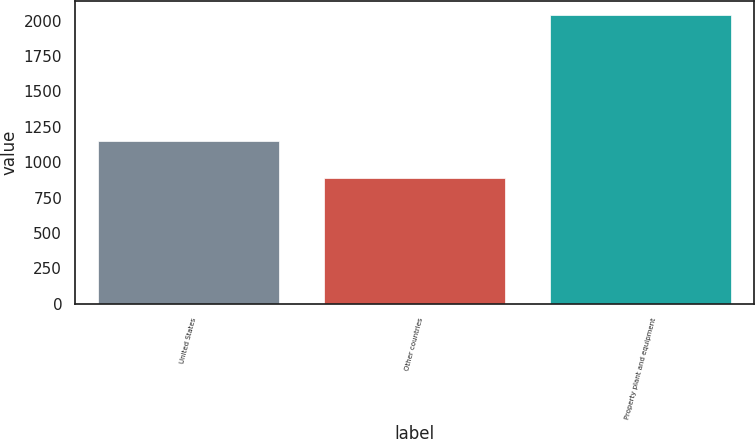Convert chart. <chart><loc_0><loc_0><loc_500><loc_500><bar_chart><fcel>United States<fcel>Other countries<fcel>Property plant and equipment<nl><fcel>1151.6<fcel>887<fcel>2038.6<nl></chart> 